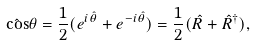Convert formula to latex. <formula><loc_0><loc_0><loc_500><loc_500>\hat { \cos } \theta = \frac { 1 } { 2 } ( e ^ { i \hat { \theta } } + e ^ { - i \hat { \theta } } ) = \frac { 1 } { 2 } ( \hat { R } + \hat { R } ^ { \dag } ) ,</formula> 